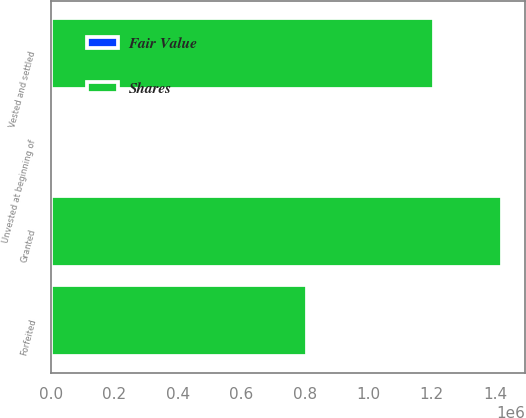Convert chart. <chart><loc_0><loc_0><loc_500><loc_500><stacked_bar_chart><ecel><fcel>Unvested at beginning of<fcel>Granted<fcel>Vested and settled<fcel>Forfeited<nl><fcel>Shares<fcel>29.53<fcel>1.42216e+06<fcel>1.20674e+06<fcel>807550<nl><fcel>Fair Value<fcel>29.18<fcel>19.37<fcel>27.08<fcel>29.53<nl></chart> 